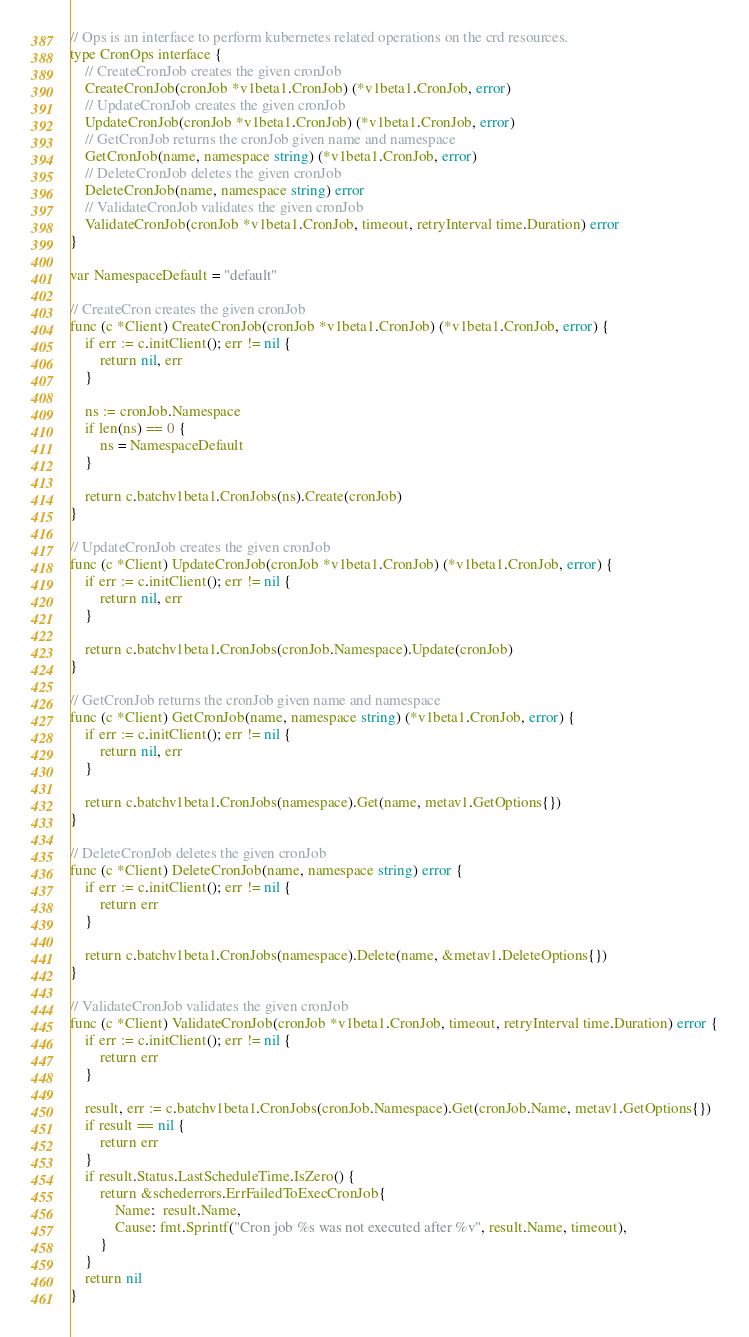Convert code to text. <code><loc_0><loc_0><loc_500><loc_500><_Go_>
// Ops is an interface to perform kubernetes related operations on the crd resources.
type CronOps interface {
	// CreateCronJob creates the given cronJob
	CreateCronJob(cronJob *v1beta1.CronJob) (*v1beta1.CronJob, error)
	// UpdateCronJob creates the given cronJob
	UpdateCronJob(cronJob *v1beta1.CronJob) (*v1beta1.CronJob, error)
	// GetCronJob returns the cronJob given name and namespace
	GetCronJob(name, namespace string) (*v1beta1.CronJob, error)
	// DeleteCronJob deletes the given cronJob
	DeleteCronJob(name, namespace string) error
	// ValidateCronJob validates the given cronJob
	ValidateCronJob(cronJob *v1beta1.CronJob, timeout, retryInterval time.Duration) error
}

var NamespaceDefault = "default"

// CreateCron creates the given cronJob
func (c *Client) CreateCronJob(cronJob *v1beta1.CronJob) (*v1beta1.CronJob, error) {
	if err := c.initClient(); err != nil {
		return nil, err
	}

	ns := cronJob.Namespace
	if len(ns) == 0 {
		ns = NamespaceDefault
	}

	return c.batchv1beta1.CronJobs(ns).Create(cronJob)
}

// UpdateCronJob creates the given cronJob
func (c *Client) UpdateCronJob(cronJob *v1beta1.CronJob) (*v1beta1.CronJob, error) {
	if err := c.initClient(); err != nil {
		return nil, err
	}

	return c.batchv1beta1.CronJobs(cronJob.Namespace).Update(cronJob)
}

// GetCronJob returns the cronJob given name and namespace
func (c *Client) GetCronJob(name, namespace string) (*v1beta1.CronJob, error) {
	if err := c.initClient(); err != nil {
		return nil, err
	}

	return c.batchv1beta1.CronJobs(namespace).Get(name, metav1.GetOptions{})
}

// DeleteCronJob deletes the given cronJob
func (c *Client) DeleteCronJob(name, namespace string) error {
	if err := c.initClient(); err != nil {
		return err
	}

	return c.batchv1beta1.CronJobs(namespace).Delete(name, &metav1.DeleteOptions{})
}

// ValidateCronJob validates the given cronJob
func (c *Client) ValidateCronJob(cronJob *v1beta1.CronJob, timeout, retryInterval time.Duration) error {
	if err := c.initClient(); err != nil {
		return err
	}

	result, err := c.batchv1beta1.CronJobs(cronJob.Namespace).Get(cronJob.Name, metav1.GetOptions{})
	if result == nil {
		return err
	}
	if result.Status.LastScheduleTime.IsZero() {
		return &schederrors.ErrFailedToExecCronJob{
			Name:  result.Name,
			Cause: fmt.Sprintf("Cron job %s was not executed after %v", result.Name, timeout),
		}
	}
	return nil
}
</code> 